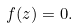<formula> <loc_0><loc_0><loc_500><loc_500>f ( z ) = 0 .</formula> 